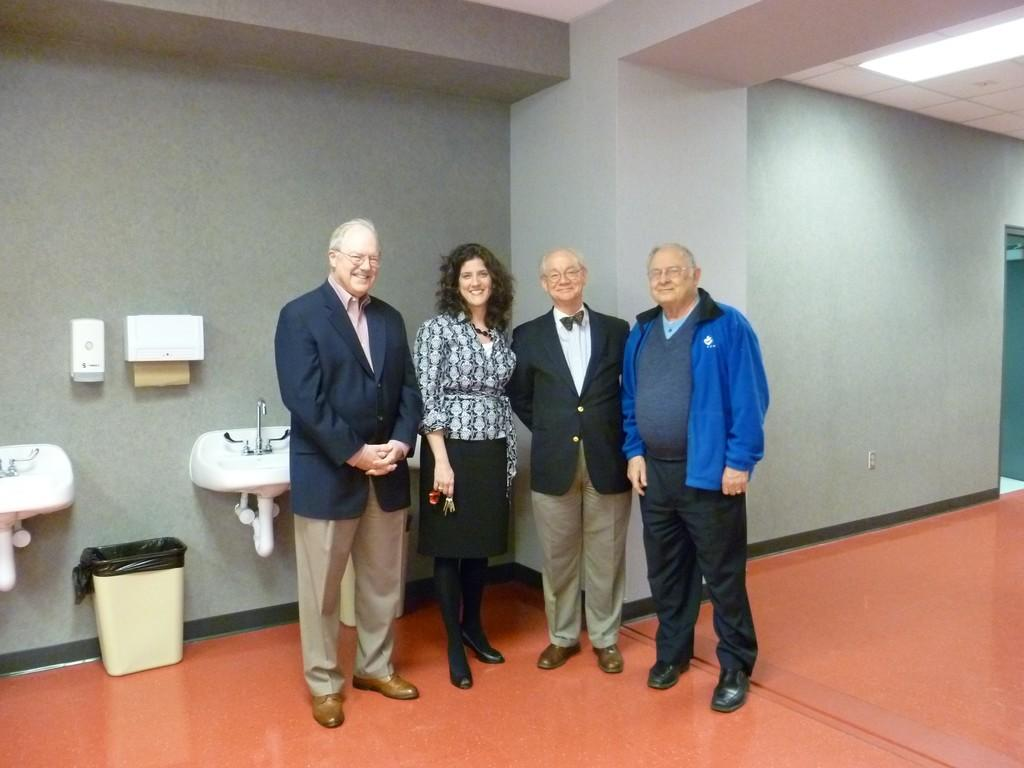What is the main subject of the image? The main subject of the image is a group of people in the center. What can be seen on the left side of the image? There are sanitary equipments and a dustbin on the left side of the image. What type of coach is present in the image? There is no coach present in the image. What material is the queen's throne made of in the image? There is no queen or throne present in the image. 